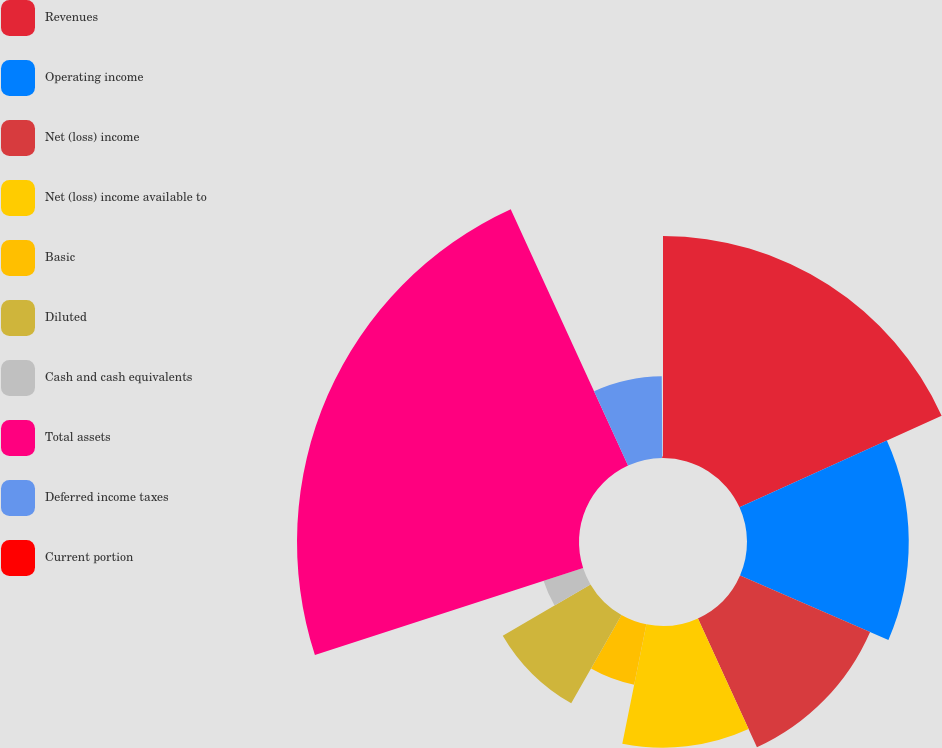Convert chart to OTSL. <chart><loc_0><loc_0><loc_500><loc_500><pie_chart><fcel>Revenues<fcel>Operating income<fcel>Net (loss) income<fcel>Net (loss) income available to<fcel>Basic<fcel>Diluted<fcel>Cash and cash equivalents<fcel>Total assets<fcel>Deferred income taxes<fcel>Current portion<nl><fcel>18.23%<fcel>13.29%<fcel>11.65%<fcel>10.0%<fcel>5.06%<fcel>8.35%<fcel>3.42%<fcel>23.17%<fcel>6.71%<fcel>0.12%<nl></chart> 